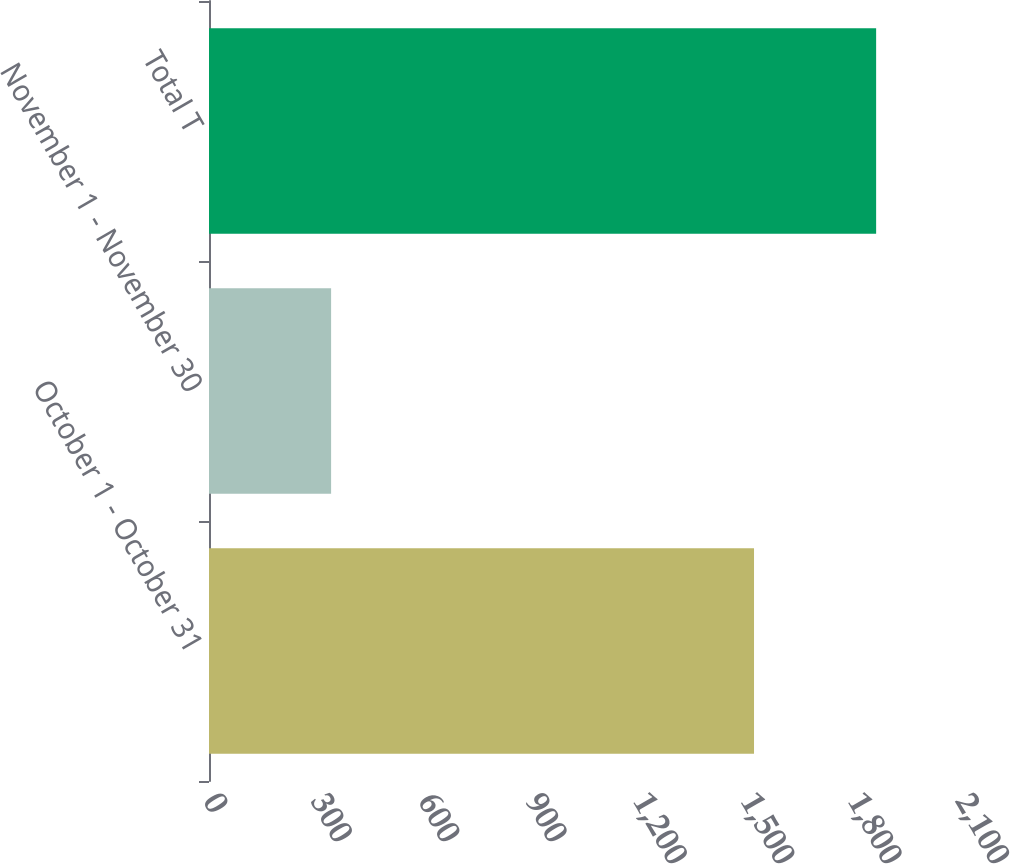Convert chart. <chart><loc_0><loc_0><loc_500><loc_500><bar_chart><fcel>October 1 - October 31<fcel>November 1 - November 30<fcel>Total T<nl><fcel>1522<fcel>341<fcel>1863<nl></chart> 